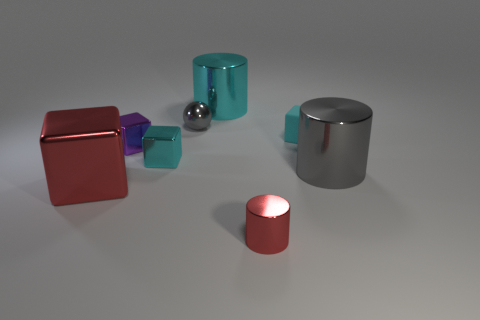Is there any other thing that has the same shape as the small gray thing?
Give a very brief answer. No. Do the purple object and the cylinder on the right side of the red cylinder have the same material?
Provide a succinct answer. Yes. There is a big object that is on the left side of the purple object; what is its color?
Provide a succinct answer. Red. Are there any big red metallic cubes on the right side of the gray shiny thing to the right of the cyan metal cylinder?
Keep it short and to the point. No. Does the large shiny thing behind the purple block have the same color as the large shiny object left of the small gray shiny ball?
Your answer should be compact. No. How many cyan blocks are to the left of the gray shiny ball?
Ensure brevity in your answer.  1. How many shiny balls are the same color as the matte block?
Keep it short and to the point. 0. Is the material of the gray object to the left of the gray shiny cylinder the same as the gray cylinder?
Your response must be concise. Yes. How many brown cubes are made of the same material as the small gray ball?
Offer a very short reply. 0. Is the number of cubes behind the tiny purple block greater than the number of small green rubber spheres?
Offer a terse response. Yes. 